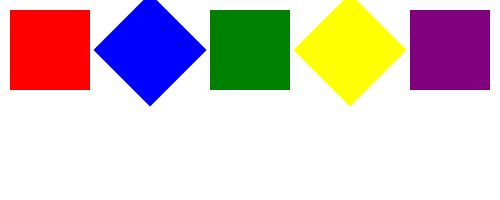In the sequence of squares shown above, what will be the color and rotation angle of the next square in the series? To determine the next square in the sequence, we need to analyze the pattern in both color and rotation:

1. Color pattern:
   Red → Blue → Green → Yellow → Purple
   The colors follow the rainbow sequence (ROYGBIV), skipping orange and indigo.

2. Rotation pattern:
   0° → 45° → 90° → 135° → 180°
   The rotation angle increases by 45° each time.

3. Predicting the next square:
   a) Color: Following the rainbow sequence, the next color after purple would be red again.
   b) Rotation: The next angle would be 180° + 45° = 225°

Therefore, the next square in the sequence would be red and rotated 225°.
Answer: Red, 225° 